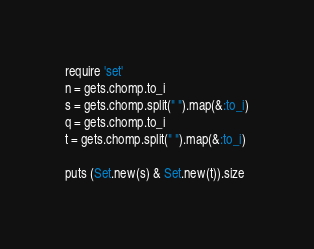Convert code to text. <code><loc_0><loc_0><loc_500><loc_500><_Ruby_>require 'set'
n = gets.chomp.to_i
s = gets.chomp.split(" ").map(&:to_i)
q = gets.chomp.to_i
t = gets.chomp.split(" ").map(&:to_i)

puts (Set.new(s) & Set.new(t)).size</code> 